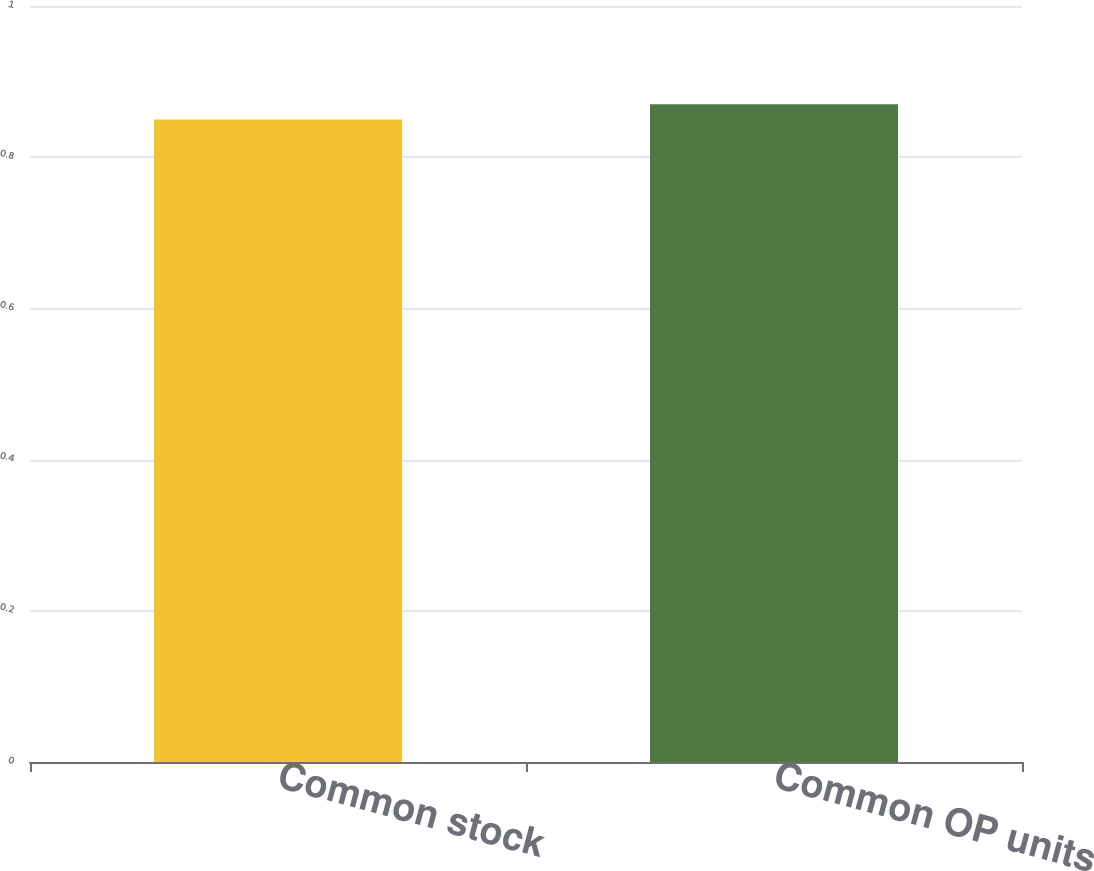Convert chart. <chart><loc_0><loc_0><loc_500><loc_500><bar_chart><fcel>Common stock<fcel>Common OP units<nl><fcel>0.85<fcel>0.87<nl></chart> 